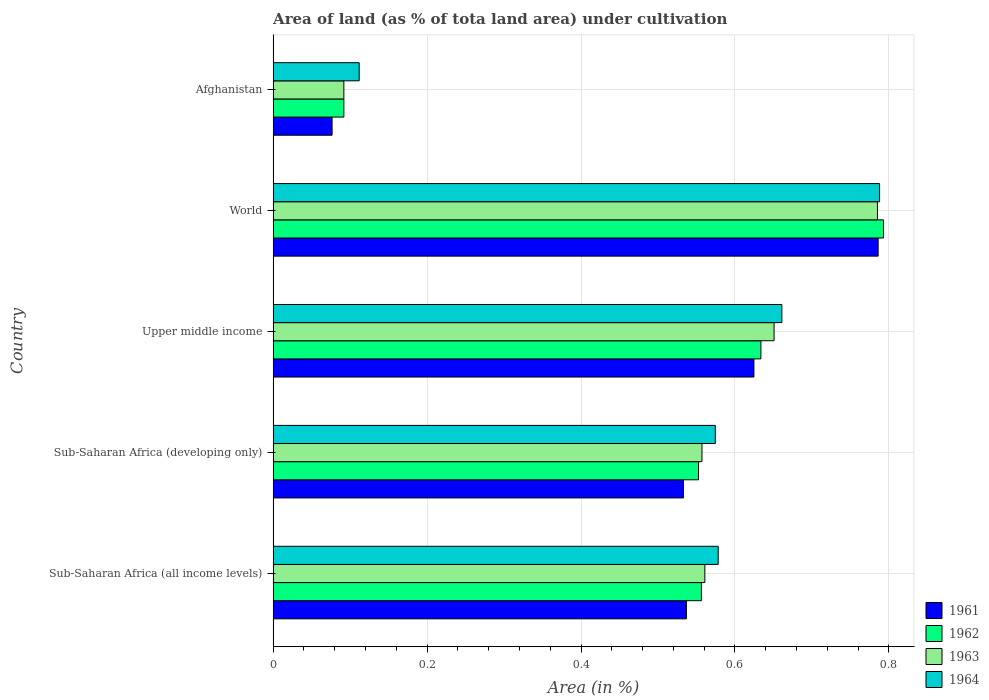How many different coloured bars are there?
Make the answer very short. 4. How many groups of bars are there?
Give a very brief answer. 5. Are the number of bars on each tick of the Y-axis equal?
Offer a very short reply. Yes. How many bars are there on the 5th tick from the top?
Your response must be concise. 4. What is the label of the 4th group of bars from the top?
Give a very brief answer. Sub-Saharan Africa (developing only). What is the percentage of land under cultivation in 1963 in Upper middle income?
Keep it short and to the point. 0.65. Across all countries, what is the maximum percentage of land under cultivation in 1961?
Make the answer very short. 0.79. Across all countries, what is the minimum percentage of land under cultivation in 1963?
Provide a succinct answer. 0.09. In which country was the percentage of land under cultivation in 1961 minimum?
Keep it short and to the point. Afghanistan. What is the total percentage of land under cultivation in 1964 in the graph?
Keep it short and to the point. 2.71. What is the difference between the percentage of land under cultivation in 1961 in Afghanistan and that in Upper middle income?
Give a very brief answer. -0.55. What is the difference between the percentage of land under cultivation in 1961 in Sub-Saharan Africa (developing only) and the percentage of land under cultivation in 1962 in Afghanistan?
Offer a terse response. 0.44. What is the average percentage of land under cultivation in 1962 per country?
Make the answer very short. 0.53. What is the difference between the percentage of land under cultivation in 1963 and percentage of land under cultivation in 1964 in Sub-Saharan Africa (all income levels)?
Your answer should be very brief. -0.02. In how many countries, is the percentage of land under cultivation in 1963 greater than 0.2 %?
Make the answer very short. 4. What is the ratio of the percentage of land under cultivation in 1963 in Afghanistan to that in Sub-Saharan Africa (all income levels)?
Your answer should be very brief. 0.16. Is the percentage of land under cultivation in 1961 in Sub-Saharan Africa (developing only) less than that in World?
Keep it short and to the point. Yes. Is the difference between the percentage of land under cultivation in 1963 in Upper middle income and World greater than the difference between the percentage of land under cultivation in 1964 in Upper middle income and World?
Offer a terse response. No. What is the difference between the highest and the second highest percentage of land under cultivation in 1964?
Keep it short and to the point. 0.13. What is the difference between the highest and the lowest percentage of land under cultivation in 1961?
Your response must be concise. 0.71. In how many countries, is the percentage of land under cultivation in 1964 greater than the average percentage of land under cultivation in 1964 taken over all countries?
Ensure brevity in your answer.  4. Is the sum of the percentage of land under cultivation in 1962 in Afghanistan and Sub-Saharan Africa (all income levels) greater than the maximum percentage of land under cultivation in 1964 across all countries?
Offer a terse response. No. Is it the case that in every country, the sum of the percentage of land under cultivation in 1962 and percentage of land under cultivation in 1964 is greater than the sum of percentage of land under cultivation in 1961 and percentage of land under cultivation in 1963?
Offer a very short reply. No. What does the 4th bar from the bottom in Sub-Saharan Africa (developing only) represents?
Ensure brevity in your answer.  1964. Is it the case that in every country, the sum of the percentage of land under cultivation in 1962 and percentage of land under cultivation in 1963 is greater than the percentage of land under cultivation in 1961?
Keep it short and to the point. Yes. How many bars are there?
Provide a succinct answer. 20. How are the legend labels stacked?
Ensure brevity in your answer.  Vertical. What is the title of the graph?
Keep it short and to the point. Area of land (as % of tota land area) under cultivation. Does "1986" appear as one of the legend labels in the graph?
Ensure brevity in your answer.  No. What is the label or title of the X-axis?
Offer a very short reply. Area (in %). What is the Area (in %) of 1961 in Sub-Saharan Africa (all income levels)?
Provide a succinct answer. 0.54. What is the Area (in %) in 1962 in Sub-Saharan Africa (all income levels)?
Your response must be concise. 0.56. What is the Area (in %) in 1963 in Sub-Saharan Africa (all income levels)?
Offer a terse response. 0.56. What is the Area (in %) of 1964 in Sub-Saharan Africa (all income levels)?
Your response must be concise. 0.58. What is the Area (in %) of 1961 in Sub-Saharan Africa (developing only)?
Give a very brief answer. 0.53. What is the Area (in %) of 1962 in Sub-Saharan Africa (developing only)?
Offer a terse response. 0.55. What is the Area (in %) of 1963 in Sub-Saharan Africa (developing only)?
Keep it short and to the point. 0.56. What is the Area (in %) in 1964 in Sub-Saharan Africa (developing only)?
Your response must be concise. 0.57. What is the Area (in %) of 1961 in Upper middle income?
Offer a very short reply. 0.62. What is the Area (in %) in 1962 in Upper middle income?
Offer a very short reply. 0.63. What is the Area (in %) in 1963 in Upper middle income?
Give a very brief answer. 0.65. What is the Area (in %) of 1964 in Upper middle income?
Make the answer very short. 0.66. What is the Area (in %) in 1961 in World?
Offer a very short reply. 0.79. What is the Area (in %) of 1962 in World?
Give a very brief answer. 0.79. What is the Area (in %) in 1963 in World?
Provide a succinct answer. 0.79. What is the Area (in %) in 1964 in World?
Offer a very short reply. 0.79. What is the Area (in %) in 1961 in Afghanistan?
Your response must be concise. 0.08. What is the Area (in %) of 1962 in Afghanistan?
Your response must be concise. 0.09. What is the Area (in %) of 1963 in Afghanistan?
Keep it short and to the point. 0.09. What is the Area (in %) of 1964 in Afghanistan?
Provide a succinct answer. 0.11. Across all countries, what is the maximum Area (in %) of 1961?
Give a very brief answer. 0.79. Across all countries, what is the maximum Area (in %) of 1962?
Offer a very short reply. 0.79. Across all countries, what is the maximum Area (in %) in 1963?
Your response must be concise. 0.79. Across all countries, what is the maximum Area (in %) in 1964?
Make the answer very short. 0.79. Across all countries, what is the minimum Area (in %) of 1961?
Offer a terse response. 0.08. Across all countries, what is the minimum Area (in %) of 1962?
Your answer should be very brief. 0.09. Across all countries, what is the minimum Area (in %) of 1963?
Offer a terse response. 0.09. Across all countries, what is the minimum Area (in %) in 1964?
Keep it short and to the point. 0.11. What is the total Area (in %) in 1961 in the graph?
Provide a short and direct response. 2.56. What is the total Area (in %) of 1962 in the graph?
Make the answer very short. 2.63. What is the total Area (in %) of 1963 in the graph?
Your answer should be compact. 2.65. What is the total Area (in %) in 1964 in the graph?
Provide a succinct answer. 2.71. What is the difference between the Area (in %) in 1961 in Sub-Saharan Africa (all income levels) and that in Sub-Saharan Africa (developing only)?
Give a very brief answer. 0. What is the difference between the Area (in %) of 1962 in Sub-Saharan Africa (all income levels) and that in Sub-Saharan Africa (developing only)?
Offer a terse response. 0. What is the difference between the Area (in %) in 1963 in Sub-Saharan Africa (all income levels) and that in Sub-Saharan Africa (developing only)?
Your answer should be very brief. 0. What is the difference between the Area (in %) of 1964 in Sub-Saharan Africa (all income levels) and that in Sub-Saharan Africa (developing only)?
Provide a succinct answer. 0. What is the difference between the Area (in %) of 1961 in Sub-Saharan Africa (all income levels) and that in Upper middle income?
Provide a succinct answer. -0.09. What is the difference between the Area (in %) of 1962 in Sub-Saharan Africa (all income levels) and that in Upper middle income?
Your answer should be compact. -0.08. What is the difference between the Area (in %) of 1963 in Sub-Saharan Africa (all income levels) and that in Upper middle income?
Provide a succinct answer. -0.09. What is the difference between the Area (in %) in 1964 in Sub-Saharan Africa (all income levels) and that in Upper middle income?
Offer a very short reply. -0.08. What is the difference between the Area (in %) of 1961 in Sub-Saharan Africa (all income levels) and that in World?
Ensure brevity in your answer.  -0.25. What is the difference between the Area (in %) of 1962 in Sub-Saharan Africa (all income levels) and that in World?
Keep it short and to the point. -0.24. What is the difference between the Area (in %) in 1963 in Sub-Saharan Africa (all income levels) and that in World?
Provide a short and direct response. -0.22. What is the difference between the Area (in %) of 1964 in Sub-Saharan Africa (all income levels) and that in World?
Keep it short and to the point. -0.21. What is the difference between the Area (in %) of 1961 in Sub-Saharan Africa (all income levels) and that in Afghanistan?
Your answer should be compact. 0.46. What is the difference between the Area (in %) in 1962 in Sub-Saharan Africa (all income levels) and that in Afghanistan?
Make the answer very short. 0.46. What is the difference between the Area (in %) of 1963 in Sub-Saharan Africa (all income levels) and that in Afghanistan?
Offer a terse response. 0.47. What is the difference between the Area (in %) of 1964 in Sub-Saharan Africa (all income levels) and that in Afghanistan?
Your answer should be very brief. 0.47. What is the difference between the Area (in %) in 1961 in Sub-Saharan Africa (developing only) and that in Upper middle income?
Provide a succinct answer. -0.09. What is the difference between the Area (in %) of 1962 in Sub-Saharan Africa (developing only) and that in Upper middle income?
Provide a succinct answer. -0.08. What is the difference between the Area (in %) of 1963 in Sub-Saharan Africa (developing only) and that in Upper middle income?
Keep it short and to the point. -0.09. What is the difference between the Area (in %) of 1964 in Sub-Saharan Africa (developing only) and that in Upper middle income?
Keep it short and to the point. -0.09. What is the difference between the Area (in %) of 1961 in Sub-Saharan Africa (developing only) and that in World?
Your answer should be very brief. -0.25. What is the difference between the Area (in %) in 1962 in Sub-Saharan Africa (developing only) and that in World?
Provide a succinct answer. -0.24. What is the difference between the Area (in %) in 1963 in Sub-Saharan Africa (developing only) and that in World?
Offer a very short reply. -0.23. What is the difference between the Area (in %) of 1964 in Sub-Saharan Africa (developing only) and that in World?
Keep it short and to the point. -0.21. What is the difference between the Area (in %) in 1961 in Sub-Saharan Africa (developing only) and that in Afghanistan?
Offer a terse response. 0.46. What is the difference between the Area (in %) in 1962 in Sub-Saharan Africa (developing only) and that in Afghanistan?
Give a very brief answer. 0.46. What is the difference between the Area (in %) of 1963 in Sub-Saharan Africa (developing only) and that in Afghanistan?
Provide a short and direct response. 0.47. What is the difference between the Area (in %) in 1964 in Sub-Saharan Africa (developing only) and that in Afghanistan?
Provide a succinct answer. 0.46. What is the difference between the Area (in %) of 1961 in Upper middle income and that in World?
Your answer should be very brief. -0.16. What is the difference between the Area (in %) of 1962 in Upper middle income and that in World?
Make the answer very short. -0.16. What is the difference between the Area (in %) of 1963 in Upper middle income and that in World?
Make the answer very short. -0.13. What is the difference between the Area (in %) of 1964 in Upper middle income and that in World?
Offer a very short reply. -0.13. What is the difference between the Area (in %) of 1961 in Upper middle income and that in Afghanistan?
Ensure brevity in your answer.  0.55. What is the difference between the Area (in %) of 1962 in Upper middle income and that in Afghanistan?
Offer a very short reply. 0.54. What is the difference between the Area (in %) of 1963 in Upper middle income and that in Afghanistan?
Offer a very short reply. 0.56. What is the difference between the Area (in %) of 1964 in Upper middle income and that in Afghanistan?
Offer a terse response. 0.55. What is the difference between the Area (in %) in 1961 in World and that in Afghanistan?
Offer a terse response. 0.71. What is the difference between the Area (in %) in 1962 in World and that in Afghanistan?
Keep it short and to the point. 0.7. What is the difference between the Area (in %) in 1963 in World and that in Afghanistan?
Your answer should be very brief. 0.69. What is the difference between the Area (in %) in 1964 in World and that in Afghanistan?
Provide a short and direct response. 0.68. What is the difference between the Area (in %) of 1961 in Sub-Saharan Africa (all income levels) and the Area (in %) of 1962 in Sub-Saharan Africa (developing only)?
Ensure brevity in your answer.  -0.02. What is the difference between the Area (in %) of 1961 in Sub-Saharan Africa (all income levels) and the Area (in %) of 1963 in Sub-Saharan Africa (developing only)?
Your answer should be very brief. -0.02. What is the difference between the Area (in %) of 1961 in Sub-Saharan Africa (all income levels) and the Area (in %) of 1964 in Sub-Saharan Africa (developing only)?
Provide a short and direct response. -0.04. What is the difference between the Area (in %) in 1962 in Sub-Saharan Africa (all income levels) and the Area (in %) in 1963 in Sub-Saharan Africa (developing only)?
Offer a terse response. -0. What is the difference between the Area (in %) of 1962 in Sub-Saharan Africa (all income levels) and the Area (in %) of 1964 in Sub-Saharan Africa (developing only)?
Your answer should be very brief. -0.02. What is the difference between the Area (in %) in 1963 in Sub-Saharan Africa (all income levels) and the Area (in %) in 1964 in Sub-Saharan Africa (developing only)?
Give a very brief answer. -0.01. What is the difference between the Area (in %) of 1961 in Sub-Saharan Africa (all income levels) and the Area (in %) of 1962 in Upper middle income?
Make the answer very short. -0.1. What is the difference between the Area (in %) in 1961 in Sub-Saharan Africa (all income levels) and the Area (in %) in 1963 in Upper middle income?
Your response must be concise. -0.11. What is the difference between the Area (in %) in 1961 in Sub-Saharan Africa (all income levels) and the Area (in %) in 1964 in Upper middle income?
Offer a very short reply. -0.12. What is the difference between the Area (in %) in 1962 in Sub-Saharan Africa (all income levels) and the Area (in %) in 1963 in Upper middle income?
Your answer should be very brief. -0.09. What is the difference between the Area (in %) in 1962 in Sub-Saharan Africa (all income levels) and the Area (in %) in 1964 in Upper middle income?
Keep it short and to the point. -0.1. What is the difference between the Area (in %) of 1963 in Sub-Saharan Africa (all income levels) and the Area (in %) of 1964 in Upper middle income?
Offer a very short reply. -0.1. What is the difference between the Area (in %) of 1961 in Sub-Saharan Africa (all income levels) and the Area (in %) of 1962 in World?
Your answer should be very brief. -0.26. What is the difference between the Area (in %) in 1961 in Sub-Saharan Africa (all income levels) and the Area (in %) in 1963 in World?
Offer a very short reply. -0.25. What is the difference between the Area (in %) in 1961 in Sub-Saharan Africa (all income levels) and the Area (in %) in 1964 in World?
Provide a succinct answer. -0.25. What is the difference between the Area (in %) of 1962 in Sub-Saharan Africa (all income levels) and the Area (in %) of 1963 in World?
Keep it short and to the point. -0.23. What is the difference between the Area (in %) in 1962 in Sub-Saharan Africa (all income levels) and the Area (in %) in 1964 in World?
Your response must be concise. -0.23. What is the difference between the Area (in %) in 1963 in Sub-Saharan Africa (all income levels) and the Area (in %) in 1964 in World?
Make the answer very short. -0.23. What is the difference between the Area (in %) of 1961 in Sub-Saharan Africa (all income levels) and the Area (in %) of 1962 in Afghanistan?
Your answer should be very brief. 0.45. What is the difference between the Area (in %) in 1961 in Sub-Saharan Africa (all income levels) and the Area (in %) in 1963 in Afghanistan?
Give a very brief answer. 0.45. What is the difference between the Area (in %) of 1961 in Sub-Saharan Africa (all income levels) and the Area (in %) of 1964 in Afghanistan?
Your answer should be compact. 0.43. What is the difference between the Area (in %) of 1962 in Sub-Saharan Africa (all income levels) and the Area (in %) of 1963 in Afghanistan?
Keep it short and to the point. 0.46. What is the difference between the Area (in %) in 1962 in Sub-Saharan Africa (all income levels) and the Area (in %) in 1964 in Afghanistan?
Offer a terse response. 0.44. What is the difference between the Area (in %) in 1963 in Sub-Saharan Africa (all income levels) and the Area (in %) in 1964 in Afghanistan?
Make the answer very short. 0.45. What is the difference between the Area (in %) of 1961 in Sub-Saharan Africa (developing only) and the Area (in %) of 1962 in Upper middle income?
Give a very brief answer. -0.1. What is the difference between the Area (in %) of 1961 in Sub-Saharan Africa (developing only) and the Area (in %) of 1963 in Upper middle income?
Your response must be concise. -0.12. What is the difference between the Area (in %) in 1961 in Sub-Saharan Africa (developing only) and the Area (in %) in 1964 in Upper middle income?
Offer a terse response. -0.13. What is the difference between the Area (in %) of 1962 in Sub-Saharan Africa (developing only) and the Area (in %) of 1963 in Upper middle income?
Offer a very short reply. -0.1. What is the difference between the Area (in %) in 1962 in Sub-Saharan Africa (developing only) and the Area (in %) in 1964 in Upper middle income?
Keep it short and to the point. -0.11. What is the difference between the Area (in %) in 1963 in Sub-Saharan Africa (developing only) and the Area (in %) in 1964 in Upper middle income?
Your response must be concise. -0.1. What is the difference between the Area (in %) in 1961 in Sub-Saharan Africa (developing only) and the Area (in %) in 1962 in World?
Keep it short and to the point. -0.26. What is the difference between the Area (in %) of 1961 in Sub-Saharan Africa (developing only) and the Area (in %) of 1963 in World?
Keep it short and to the point. -0.25. What is the difference between the Area (in %) of 1961 in Sub-Saharan Africa (developing only) and the Area (in %) of 1964 in World?
Provide a succinct answer. -0.25. What is the difference between the Area (in %) of 1962 in Sub-Saharan Africa (developing only) and the Area (in %) of 1963 in World?
Your answer should be very brief. -0.23. What is the difference between the Area (in %) in 1962 in Sub-Saharan Africa (developing only) and the Area (in %) in 1964 in World?
Offer a very short reply. -0.24. What is the difference between the Area (in %) of 1963 in Sub-Saharan Africa (developing only) and the Area (in %) of 1964 in World?
Offer a very short reply. -0.23. What is the difference between the Area (in %) of 1961 in Sub-Saharan Africa (developing only) and the Area (in %) of 1962 in Afghanistan?
Ensure brevity in your answer.  0.44. What is the difference between the Area (in %) in 1961 in Sub-Saharan Africa (developing only) and the Area (in %) in 1963 in Afghanistan?
Provide a succinct answer. 0.44. What is the difference between the Area (in %) in 1961 in Sub-Saharan Africa (developing only) and the Area (in %) in 1964 in Afghanistan?
Offer a very short reply. 0.42. What is the difference between the Area (in %) of 1962 in Sub-Saharan Africa (developing only) and the Area (in %) of 1963 in Afghanistan?
Ensure brevity in your answer.  0.46. What is the difference between the Area (in %) of 1962 in Sub-Saharan Africa (developing only) and the Area (in %) of 1964 in Afghanistan?
Give a very brief answer. 0.44. What is the difference between the Area (in %) of 1963 in Sub-Saharan Africa (developing only) and the Area (in %) of 1964 in Afghanistan?
Ensure brevity in your answer.  0.45. What is the difference between the Area (in %) of 1961 in Upper middle income and the Area (in %) of 1962 in World?
Your response must be concise. -0.17. What is the difference between the Area (in %) in 1961 in Upper middle income and the Area (in %) in 1963 in World?
Give a very brief answer. -0.16. What is the difference between the Area (in %) in 1961 in Upper middle income and the Area (in %) in 1964 in World?
Provide a short and direct response. -0.16. What is the difference between the Area (in %) in 1962 in Upper middle income and the Area (in %) in 1963 in World?
Ensure brevity in your answer.  -0.15. What is the difference between the Area (in %) in 1962 in Upper middle income and the Area (in %) in 1964 in World?
Provide a succinct answer. -0.15. What is the difference between the Area (in %) of 1963 in Upper middle income and the Area (in %) of 1964 in World?
Give a very brief answer. -0.14. What is the difference between the Area (in %) of 1961 in Upper middle income and the Area (in %) of 1962 in Afghanistan?
Ensure brevity in your answer.  0.53. What is the difference between the Area (in %) of 1961 in Upper middle income and the Area (in %) of 1963 in Afghanistan?
Keep it short and to the point. 0.53. What is the difference between the Area (in %) of 1961 in Upper middle income and the Area (in %) of 1964 in Afghanistan?
Your answer should be compact. 0.51. What is the difference between the Area (in %) in 1962 in Upper middle income and the Area (in %) in 1963 in Afghanistan?
Your answer should be very brief. 0.54. What is the difference between the Area (in %) in 1962 in Upper middle income and the Area (in %) in 1964 in Afghanistan?
Ensure brevity in your answer.  0.52. What is the difference between the Area (in %) of 1963 in Upper middle income and the Area (in %) of 1964 in Afghanistan?
Ensure brevity in your answer.  0.54. What is the difference between the Area (in %) of 1961 in World and the Area (in %) of 1962 in Afghanistan?
Give a very brief answer. 0.69. What is the difference between the Area (in %) in 1961 in World and the Area (in %) in 1963 in Afghanistan?
Your response must be concise. 0.69. What is the difference between the Area (in %) of 1961 in World and the Area (in %) of 1964 in Afghanistan?
Offer a terse response. 0.67. What is the difference between the Area (in %) in 1962 in World and the Area (in %) in 1963 in Afghanistan?
Give a very brief answer. 0.7. What is the difference between the Area (in %) in 1962 in World and the Area (in %) in 1964 in Afghanistan?
Ensure brevity in your answer.  0.68. What is the difference between the Area (in %) in 1963 in World and the Area (in %) in 1964 in Afghanistan?
Your answer should be compact. 0.67. What is the average Area (in %) of 1961 per country?
Give a very brief answer. 0.51. What is the average Area (in %) in 1962 per country?
Your answer should be compact. 0.53. What is the average Area (in %) in 1963 per country?
Your answer should be very brief. 0.53. What is the average Area (in %) of 1964 per country?
Give a very brief answer. 0.54. What is the difference between the Area (in %) in 1961 and Area (in %) in 1962 in Sub-Saharan Africa (all income levels)?
Provide a succinct answer. -0.02. What is the difference between the Area (in %) of 1961 and Area (in %) of 1963 in Sub-Saharan Africa (all income levels)?
Provide a short and direct response. -0.02. What is the difference between the Area (in %) of 1961 and Area (in %) of 1964 in Sub-Saharan Africa (all income levels)?
Ensure brevity in your answer.  -0.04. What is the difference between the Area (in %) in 1962 and Area (in %) in 1963 in Sub-Saharan Africa (all income levels)?
Give a very brief answer. -0. What is the difference between the Area (in %) in 1962 and Area (in %) in 1964 in Sub-Saharan Africa (all income levels)?
Make the answer very short. -0.02. What is the difference between the Area (in %) in 1963 and Area (in %) in 1964 in Sub-Saharan Africa (all income levels)?
Your answer should be compact. -0.02. What is the difference between the Area (in %) of 1961 and Area (in %) of 1962 in Sub-Saharan Africa (developing only)?
Offer a terse response. -0.02. What is the difference between the Area (in %) in 1961 and Area (in %) in 1963 in Sub-Saharan Africa (developing only)?
Provide a short and direct response. -0.02. What is the difference between the Area (in %) of 1961 and Area (in %) of 1964 in Sub-Saharan Africa (developing only)?
Give a very brief answer. -0.04. What is the difference between the Area (in %) of 1962 and Area (in %) of 1963 in Sub-Saharan Africa (developing only)?
Offer a terse response. -0. What is the difference between the Area (in %) of 1962 and Area (in %) of 1964 in Sub-Saharan Africa (developing only)?
Ensure brevity in your answer.  -0.02. What is the difference between the Area (in %) of 1963 and Area (in %) of 1964 in Sub-Saharan Africa (developing only)?
Ensure brevity in your answer.  -0.02. What is the difference between the Area (in %) of 1961 and Area (in %) of 1962 in Upper middle income?
Provide a short and direct response. -0.01. What is the difference between the Area (in %) in 1961 and Area (in %) in 1963 in Upper middle income?
Offer a very short reply. -0.03. What is the difference between the Area (in %) in 1961 and Area (in %) in 1964 in Upper middle income?
Your answer should be compact. -0.04. What is the difference between the Area (in %) in 1962 and Area (in %) in 1963 in Upper middle income?
Keep it short and to the point. -0.02. What is the difference between the Area (in %) of 1962 and Area (in %) of 1964 in Upper middle income?
Provide a short and direct response. -0.03. What is the difference between the Area (in %) of 1963 and Area (in %) of 1964 in Upper middle income?
Ensure brevity in your answer.  -0.01. What is the difference between the Area (in %) in 1961 and Area (in %) in 1962 in World?
Ensure brevity in your answer.  -0.01. What is the difference between the Area (in %) of 1961 and Area (in %) of 1963 in World?
Offer a very short reply. 0. What is the difference between the Area (in %) of 1961 and Area (in %) of 1964 in World?
Offer a terse response. -0. What is the difference between the Area (in %) in 1962 and Area (in %) in 1963 in World?
Your answer should be very brief. 0.01. What is the difference between the Area (in %) of 1962 and Area (in %) of 1964 in World?
Provide a short and direct response. 0.01. What is the difference between the Area (in %) of 1963 and Area (in %) of 1964 in World?
Your response must be concise. -0. What is the difference between the Area (in %) in 1961 and Area (in %) in 1962 in Afghanistan?
Offer a very short reply. -0.02. What is the difference between the Area (in %) of 1961 and Area (in %) of 1963 in Afghanistan?
Give a very brief answer. -0.02. What is the difference between the Area (in %) in 1961 and Area (in %) in 1964 in Afghanistan?
Provide a succinct answer. -0.04. What is the difference between the Area (in %) of 1962 and Area (in %) of 1964 in Afghanistan?
Give a very brief answer. -0.02. What is the difference between the Area (in %) of 1963 and Area (in %) of 1964 in Afghanistan?
Your answer should be compact. -0.02. What is the ratio of the Area (in %) of 1961 in Sub-Saharan Africa (all income levels) to that in Sub-Saharan Africa (developing only)?
Provide a succinct answer. 1.01. What is the ratio of the Area (in %) of 1962 in Sub-Saharan Africa (all income levels) to that in Sub-Saharan Africa (developing only)?
Make the answer very short. 1.01. What is the ratio of the Area (in %) of 1964 in Sub-Saharan Africa (all income levels) to that in Sub-Saharan Africa (developing only)?
Ensure brevity in your answer.  1.01. What is the ratio of the Area (in %) in 1961 in Sub-Saharan Africa (all income levels) to that in Upper middle income?
Offer a very short reply. 0.86. What is the ratio of the Area (in %) of 1962 in Sub-Saharan Africa (all income levels) to that in Upper middle income?
Your answer should be very brief. 0.88. What is the ratio of the Area (in %) in 1963 in Sub-Saharan Africa (all income levels) to that in Upper middle income?
Provide a short and direct response. 0.86. What is the ratio of the Area (in %) in 1964 in Sub-Saharan Africa (all income levels) to that in Upper middle income?
Your answer should be very brief. 0.87. What is the ratio of the Area (in %) of 1961 in Sub-Saharan Africa (all income levels) to that in World?
Your answer should be very brief. 0.68. What is the ratio of the Area (in %) of 1962 in Sub-Saharan Africa (all income levels) to that in World?
Your answer should be very brief. 0.7. What is the ratio of the Area (in %) of 1963 in Sub-Saharan Africa (all income levels) to that in World?
Ensure brevity in your answer.  0.71. What is the ratio of the Area (in %) of 1964 in Sub-Saharan Africa (all income levels) to that in World?
Give a very brief answer. 0.73. What is the ratio of the Area (in %) of 1961 in Sub-Saharan Africa (all income levels) to that in Afghanistan?
Keep it short and to the point. 7.01. What is the ratio of the Area (in %) in 1962 in Sub-Saharan Africa (all income levels) to that in Afghanistan?
Offer a terse response. 6.05. What is the ratio of the Area (in %) of 1963 in Sub-Saharan Africa (all income levels) to that in Afghanistan?
Your answer should be compact. 6.1. What is the ratio of the Area (in %) in 1964 in Sub-Saharan Africa (all income levels) to that in Afghanistan?
Keep it short and to the point. 5.17. What is the ratio of the Area (in %) of 1961 in Sub-Saharan Africa (developing only) to that in Upper middle income?
Your answer should be compact. 0.85. What is the ratio of the Area (in %) in 1962 in Sub-Saharan Africa (developing only) to that in Upper middle income?
Your answer should be compact. 0.87. What is the ratio of the Area (in %) in 1963 in Sub-Saharan Africa (developing only) to that in Upper middle income?
Your answer should be very brief. 0.86. What is the ratio of the Area (in %) of 1964 in Sub-Saharan Africa (developing only) to that in Upper middle income?
Make the answer very short. 0.87. What is the ratio of the Area (in %) of 1961 in Sub-Saharan Africa (developing only) to that in World?
Keep it short and to the point. 0.68. What is the ratio of the Area (in %) in 1962 in Sub-Saharan Africa (developing only) to that in World?
Your response must be concise. 0.7. What is the ratio of the Area (in %) in 1963 in Sub-Saharan Africa (developing only) to that in World?
Give a very brief answer. 0.71. What is the ratio of the Area (in %) in 1964 in Sub-Saharan Africa (developing only) to that in World?
Provide a succinct answer. 0.73. What is the ratio of the Area (in %) of 1961 in Sub-Saharan Africa (developing only) to that in Afghanistan?
Provide a short and direct response. 6.96. What is the ratio of the Area (in %) in 1962 in Sub-Saharan Africa (developing only) to that in Afghanistan?
Provide a succinct answer. 6.01. What is the ratio of the Area (in %) in 1963 in Sub-Saharan Africa (developing only) to that in Afghanistan?
Provide a short and direct response. 6.06. What is the ratio of the Area (in %) in 1964 in Sub-Saharan Africa (developing only) to that in Afghanistan?
Ensure brevity in your answer.  5.14. What is the ratio of the Area (in %) in 1961 in Upper middle income to that in World?
Your answer should be compact. 0.79. What is the ratio of the Area (in %) in 1962 in Upper middle income to that in World?
Provide a succinct answer. 0.8. What is the ratio of the Area (in %) of 1963 in Upper middle income to that in World?
Make the answer very short. 0.83. What is the ratio of the Area (in %) in 1964 in Upper middle income to that in World?
Offer a terse response. 0.84. What is the ratio of the Area (in %) in 1961 in Upper middle income to that in Afghanistan?
Your answer should be very brief. 8.16. What is the ratio of the Area (in %) of 1962 in Upper middle income to that in Afghanistan?
Your answer should be compact. 6.9. What is the ratio of the Area (in %) of 1963 in Upper middle income to that in Afghanistan?
Offer a terse response. 7.08. What is the ratio of the Area (in %) of 1964 in Upper middle income to that in Afghanistan?
Your answer should be compact. 5.91. What is the ratio of the Area (in %) in 1961 in World to that in Afghanistan?
Ensure brevity in your answer.  10.26. What is the ratio of the Area (in %) in 1962 in World to that in Afghanistan?
Your answer should be very brief. 8.63. What is the ratio of the Area (in %) in 1963 in World to that in Afghanistan?
Your answer should be very brief. 8.54. What is the ratio of the Area (in %) in 1964 in World to that in Afghanistan?
Offer a very short reply. 7.05. What is the difference between the highest and the second highest Area (in %) of 1961?
Ensure brevity in your answer.  0.16. What is the difference between the highest and the second highest Area (in %) in 1962?
Provide a short and direct response. 0.16. What is the difference between the highest and the second highest Area (in %) in 1963?
Your answer should be very brief. 0.13. What is the difference between the highest and the second highest Area (in %) in 1964?
Provide a succinct answer. 0.13. What is the difference between the highest and the lowest Area (in %) in 1961?
Ensure brevity in your answer.  0.71. What is the difference between the highest and the lowest Area (in %) of 1962?
Provide a succinct answer. 0.7. What is the difference between the highest and the lowest Area (in %) in 1963?
Provide a short and direct response. 0.69. What is the difference between the highest and the lowest Area (in %) of 1964?
Give a very brief answer. 0.68. 